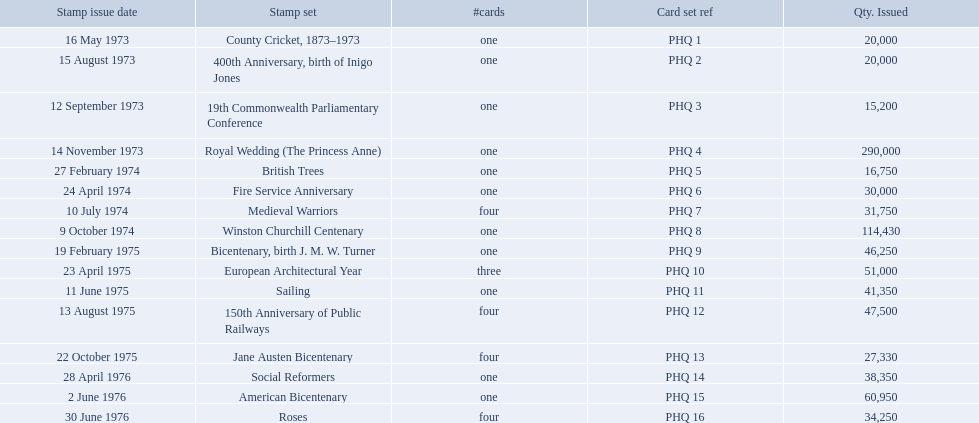What are all the stamp sets? County Cricket, 1873–1973, 400th Anniversary, birth of Inigo Jones, 19th Commonwealth Parliamentary Conference, Royal Wedding (The Princess Anne), British Trees, Fire Service Anniversary, Medieval Warriors, Winston Churchill Centenary, Bicentenary, birth J. M. W. Turner, European Architectural Year, Sailing, 150th Anniversary of Public Railways, Jane Austen Bicentenary, Social Reformers, American Bicentenary, Roses. For these sets, what were the quantities issued? 20,000, 20,000, 15,200, 290,000, 16,750, 30,000, 31,750, 114,430, 46,250, 51,000, 41,350, 47,500, 27,330, 38,350, 60,950, 34,250. Of these, which quantity is above 200,000? 290,000. What is the stamp set corresponding to this quantity? Royal Wedding (The Princess Anne). Which are the stamp sets in the phq? County Cricket, 1873–1973, 400th Anniversary, birth of Inigo Jones, 19th Commonwealth Parliamentary Conference, Royal Wedding (The Princess Anne), British Trees, Fire Service Anniversary, Medieval Warriors, Winston Churchill Centenary, Bicentenary, birth J. M. W. Turner, European Architectural Year, Sailing, 150th Anniversary of Public Railways, Jane Austen Bicentenary, Social Reformers, American Bicentenary, Roses. Which stamp sets have higher than 200,000 quantity issued? Royal Wedding (The Princess Anne). Which stamp sets had three or more cards? Medieval Warriors, European Architectural Year, 150th Anniversary of Public Railways, Jane Austen Bicentenary, Roses. Of those, which one only has three cards? European Architectural Year. Which stamp series had more than one card? Medieval Warriors, European Architectural Year, 150th Anniversary of Public Railways, Jane Austen Bicentenary, Roses. Among those series, which possesses a unique count of cards? European Architectural Year. Would you be able to parse every entry in this table? {'header': ['Stamp issue date', 'Stamp set', '#cards', 'Card set ref', 'Qty. Issued'], 'rows': [['16 May 1973', 'County Cricket, 1873–1973', 'one', 'PHQ 1', '20,000'], ['15 August 1973', '400th Anniversary, birth of Inigo Jones', 'one', 'PHQ 2', '20,000'], ['12 September 1973', '19th Commonwealth Parliamentary Conference', 'one', 'PHQ 3', '15,200'], ['14 November 1973', 'Royal Wedding (The Princess Anne)', 'one', 'PHQ 4', '290,000'], ['27 February 1974', 'British Trees', 'one', 'PHQ 5', '16,750'], ['24 April 1974', 'Fire Service Anniversary', 'one', 'PHQ 6', '30,000'], ['10 July 1974', 'Medieval Warriors', 'four', 'PHQ 7', '31,750'], ['9 October 1974', 'Winston Churchill Centenary', 'one', 'PHQ 8', '114,430'], ['19 February 1975', 'Bicentenary, birth J. M. W. Turner', 'one', 'PHQ 9', '46,250'], ['23 April 1975', 'European Architectural Year', 'three', 'PHQ 10', '51,000'], ['11 June 1975', 'Sailing', 'one', 'PHQ 11', '41,350'], ['13 August 1975', '150th Anniversary of Public Railways', 'four', 'PHQ 12', '47,500'], ['22 October 1975', 'Jane Austen Bicentenary', 'four', 'PHQ 13', '27,330'], ['28 April 1976', 'Social Reformers', 'one', 'PHQ 14', '38,350'], ['2 June 1976', 'American Bicentenary', 'one', 'PHQ 15', '60,950'], ['30 June 1976', 'Roses', 'four', 'PHQ 16', '34,250']]} Can you name the stamp sets within the phq? County Cricket, 1873–1973, 400th Anniversary, birth of Inigo Jones, 19th Commonwealth Parliamentary Conference, Royal Wedding (The Princess Anne), British Trees, Fire Service Anniversary, Medieval Warriors, Winston Churchill Centenary, Bicentenary, birth J. M. W. Turner, European Architectural Year, Sailing, 150th Anniversary of Public Railways, Jane Austen Bicentenary, Social Reformers, American Bicentenary, Roses. Which of these sets have more than 200,000 copies issued? Royal Wedding (The Princess Anne). What are the various stamp sets available? County Cricket, 1873–1973, 400th Anniversary, birth of Inigo Jones, 19th Commonwealth Parliamentary Conference, Royal Wedding (The Princess Anne), British Trees, Fire Service Anniversary, Medieval Warriors, Winston Churchill Centenary, Bicentenary, birth J. M. W. Turner, European Architectural Year, Sailing, 150th Anniversary of Public Railways, Jane Austen Bicentenary, Social Reformers, American Bicentenary, Roses. Among them, which set contains three cards? European Architectural Year. In which stamp sets can more than one card be found? Medieval Warriors, European Architectural Year, 150th Anniversary of Public Railways, Jane Austen Bicentenary, Roses. Among these sets, which one has a distinct number of cards? European Architectural Year. In which stamp sets are there multiple cards? Medieval Warriors, European Architectural Year, 150th Anniversary of Public Railways, Jane Austen Bicentenary, Roses. Out of these sets, which one possesses a one-of-a-kind card count? European Architectural Year. 